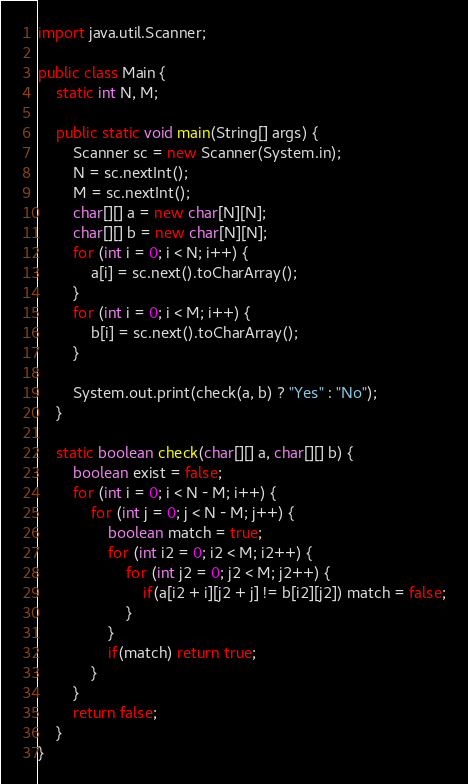Convert code to text. <code><loc_0><loc_0><loc_500><loc_500><_Java_>import java.util.Scanner;

public class Main {
	static int N, M;

	public static void main(String[] args) {
		Scanner sc = new Scanner(System.in);
		N = sc.nextInt();
		M = sc.nextInt();
		char[][] a = new char[N][N];
		char[][] b = new char[N][N];
		for (int i = 0; i < N; i++) {
			a[i] = sc.next().toCharArray();
		}
		for (int i = 0; i < M; i++) {
			b[i] = sc.next().toCharArray();
		}

		System.out.print(check(a, b) ? "Yes" : "No");
	}

	static boolean check(char[][] a, char[][] b) {
		boolean exist = false;
		for (int i = 0; i < N - M; i++) {
			for (int j = 0; j < N - M; j++) {
				boolean match = true;
				for (int i2 = 0; i2 < M; i2++) {
					for (int j2 = 0; j2 < M; j2++) {
						if(a[i2 + i][j2 + j] != b[i2][j2]) match = false;
					}
				}
				if(match) return true;
			}
		}
		return false;
	}
}

</code> 